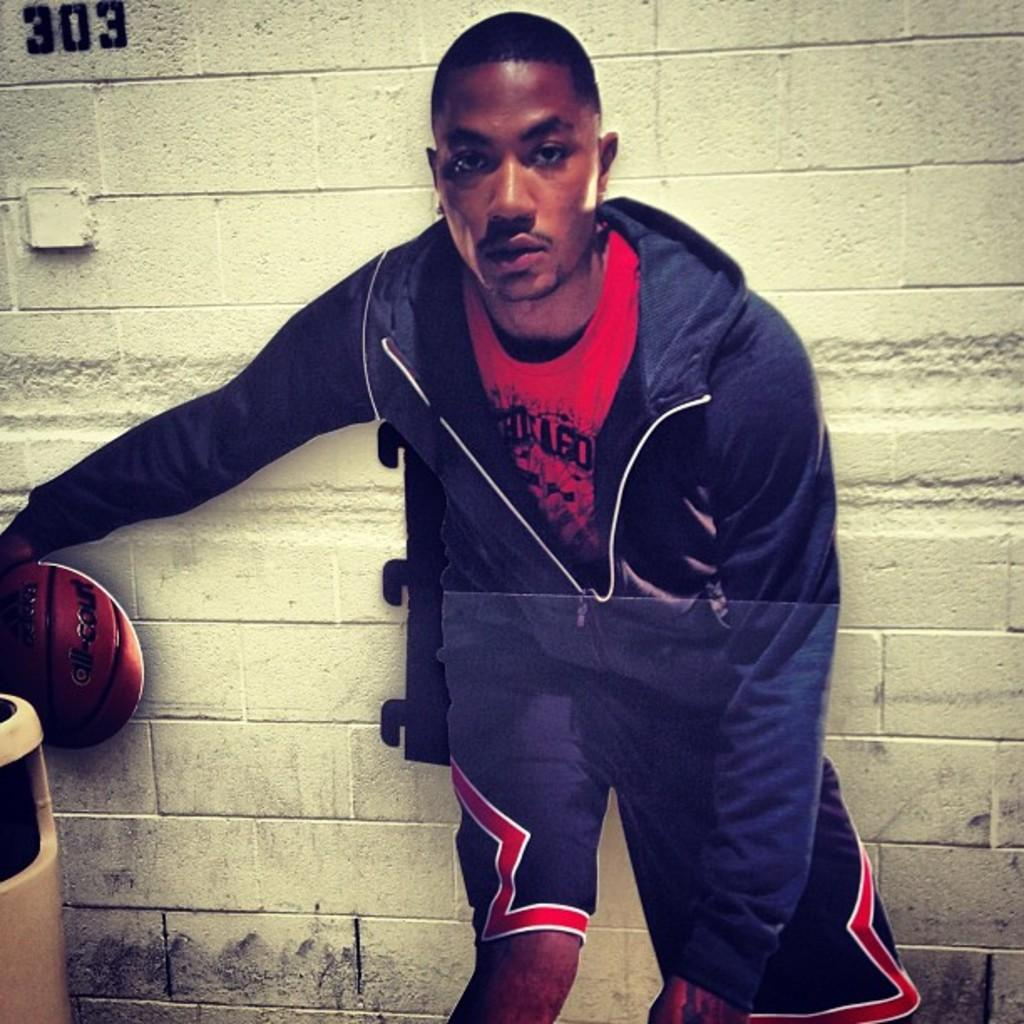<image>
Provide a brief description of the given image. a basketball players with a ball and a wall behind him with the number 303 